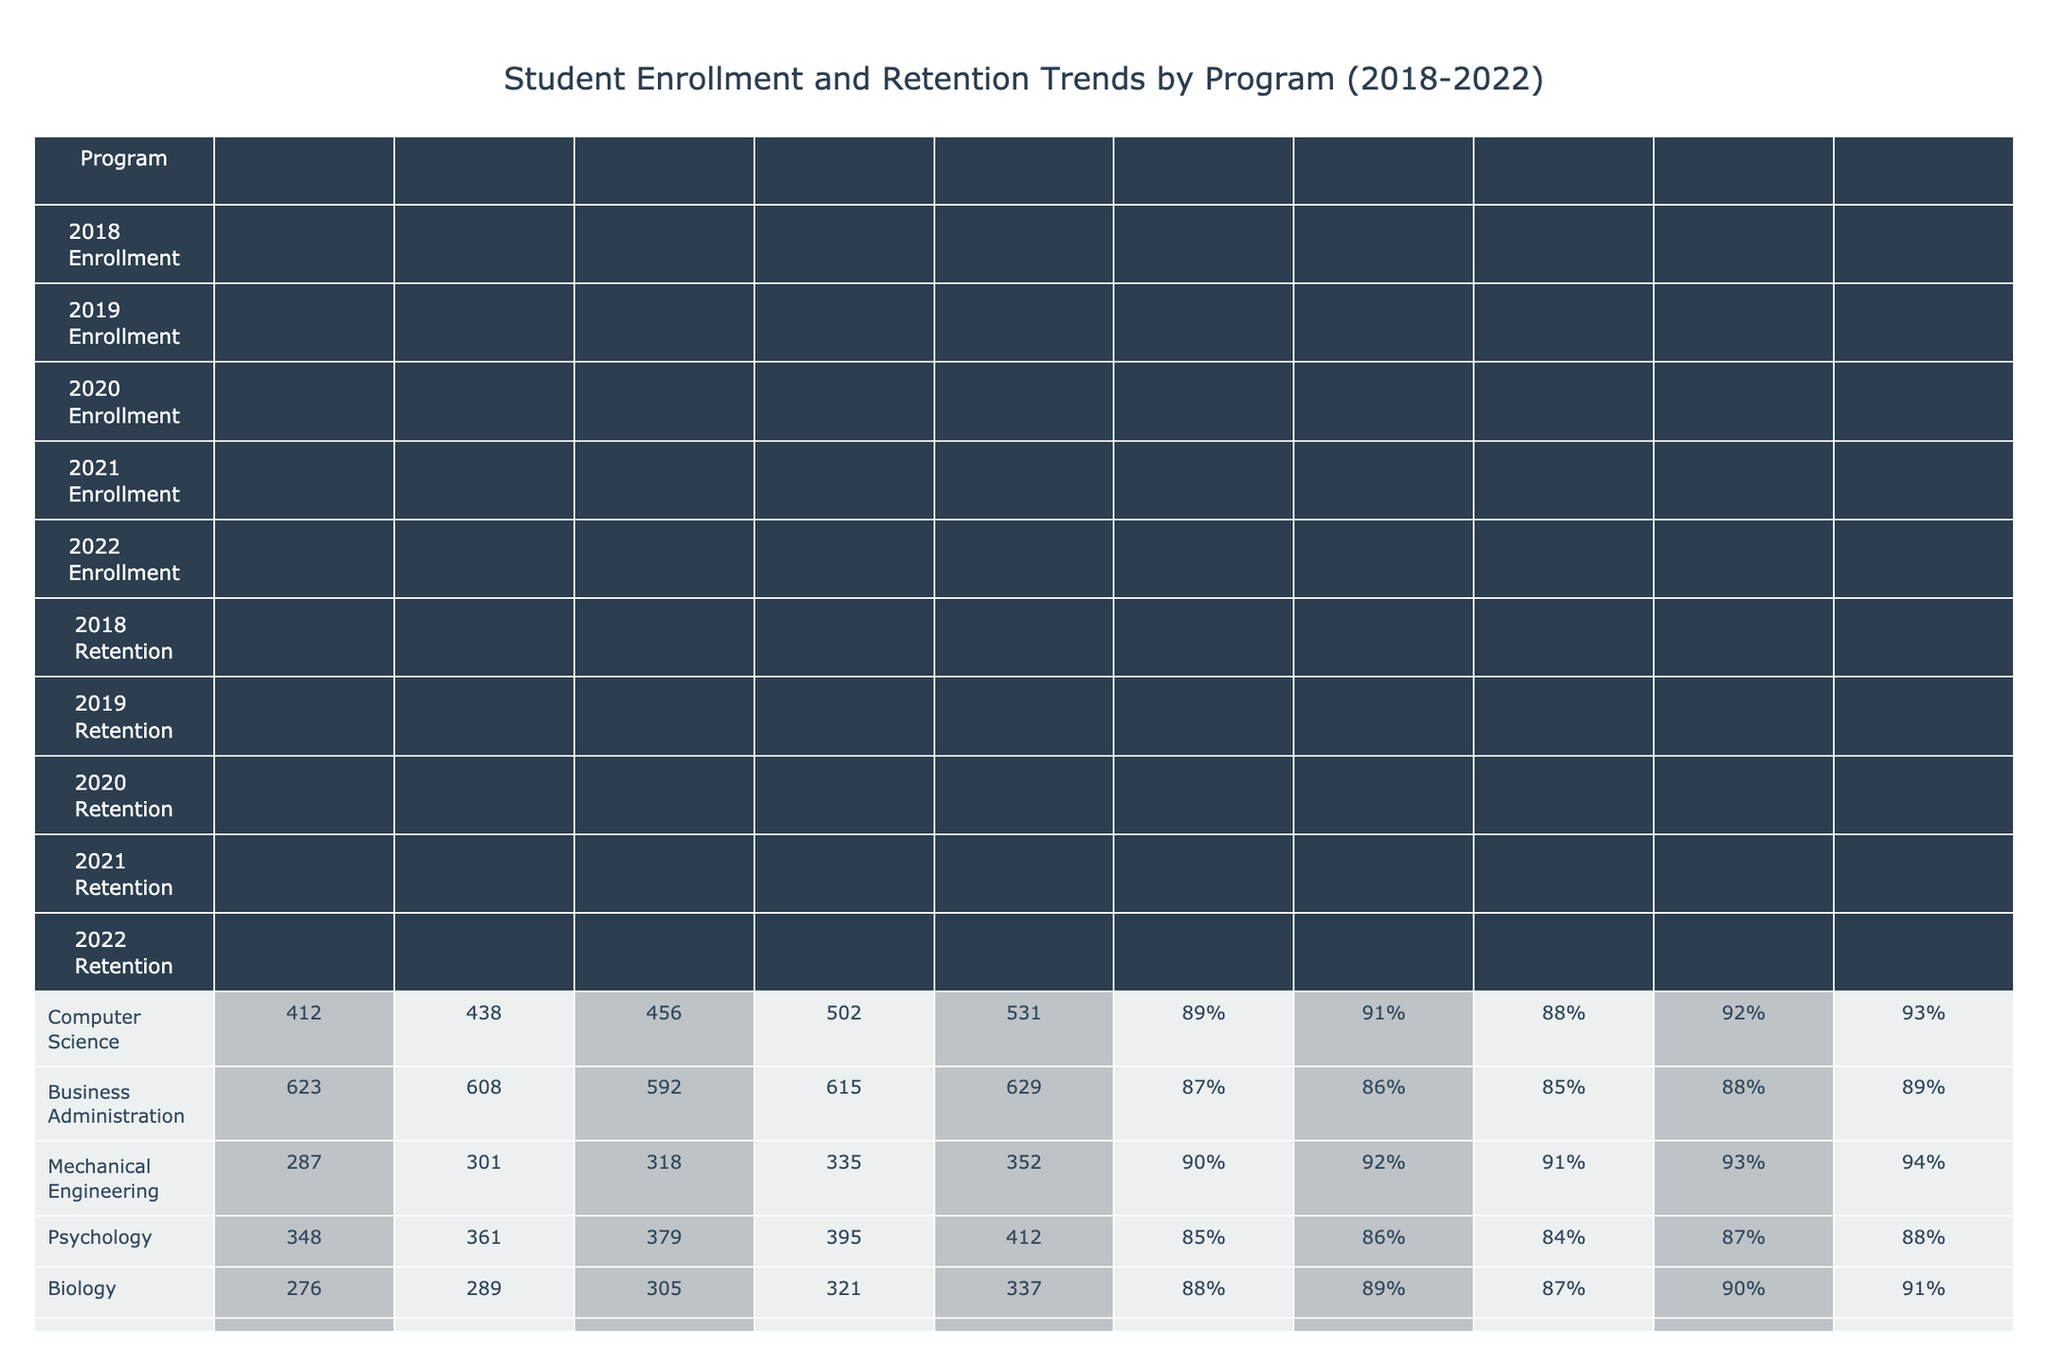What was the enrollment for the Nursing program in 2020? The table shows that the Nursing program had an enrollment of 432 in the year 2020.
Answer: 432 Which program had the highest retention rate in 2021? By looking at the retention rates for 2021, Nursing had a retention rate of 93%, which is the highest among all programs listed.
Answer: Nursing What was the average enrollment for the Biology program from 2018 to 2022? The enrollment figures for Biology from 2018 to 2022 are 276, 289, 305, 321, and 337. Adding these gives 1528 and dividing by 5 gives an average of 305.6.
Answer: 305.6 Did the Computer Science program experience an increase in enrollment from 2018 to 2022? The enrollment figures for Computer Science are 412 in 2018 and 531 in 2022. Since 531 is greater than 412, the program did experience an increase.
Answer: Yes What is the difference in enrollment between Business Administration in 2018 and 2022? The enrollment for Business Administration was 623 in 2018 and 629 in 2022. The difference is 629 - 623 = 6.
Answer: 6 Which program showed the most consistent retention rates over the years? Looking at the retention rates, Mechanical Engineering shows an increase from 90% to 94% with no decline, indicating consistency over the years as it never dropped below 90%.
Answer: Mechanical Engineering What was the total enrollment across all programs for the year 2019? Summing up the 2019 enrollments: 438 (Computer Science) + 608 (Business Administration) + 301 (Mechanical Engineering) + 361 (Psychology) + 289 (Biology) + 172 (English Literature) + 258 (Economics) + 411 (Nursing) + 175 (Political Science) + 165 (Chemistry) + 148 (Sociology) + 136 (Mathematics) + 106 (History) + 103 (Physics) + 215 (Art and Design) equals a total of 5514.
Answer: 5514 Was the enrollment in the Psychology program increasing every year from 2018 to 2022? Examining the enrollments for Psychology reveals a steady increase from 348 in 2018 to 412 in 2022, showing consistent growth throughout those years.
Answer: Yes What retention rate did the Chemistry program reach by 2022? The table lists Chemistry's retention rate in 2022 as 90%.
Answer: 90% Which program had the lowest enrollment in 2018? The table indicates that English Literature had the lowest enrollment in 2018 at 183.
Answer: English Literature 